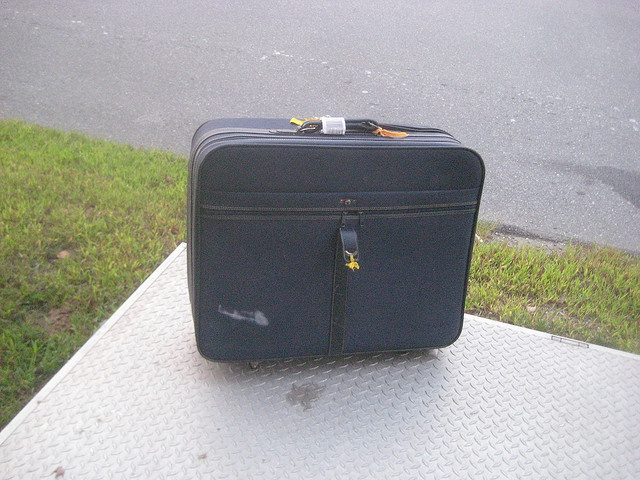Describe the objects in this image and their specific colors. I can see a suitcase in darkgray, gray, purple, and black tones in this image. 